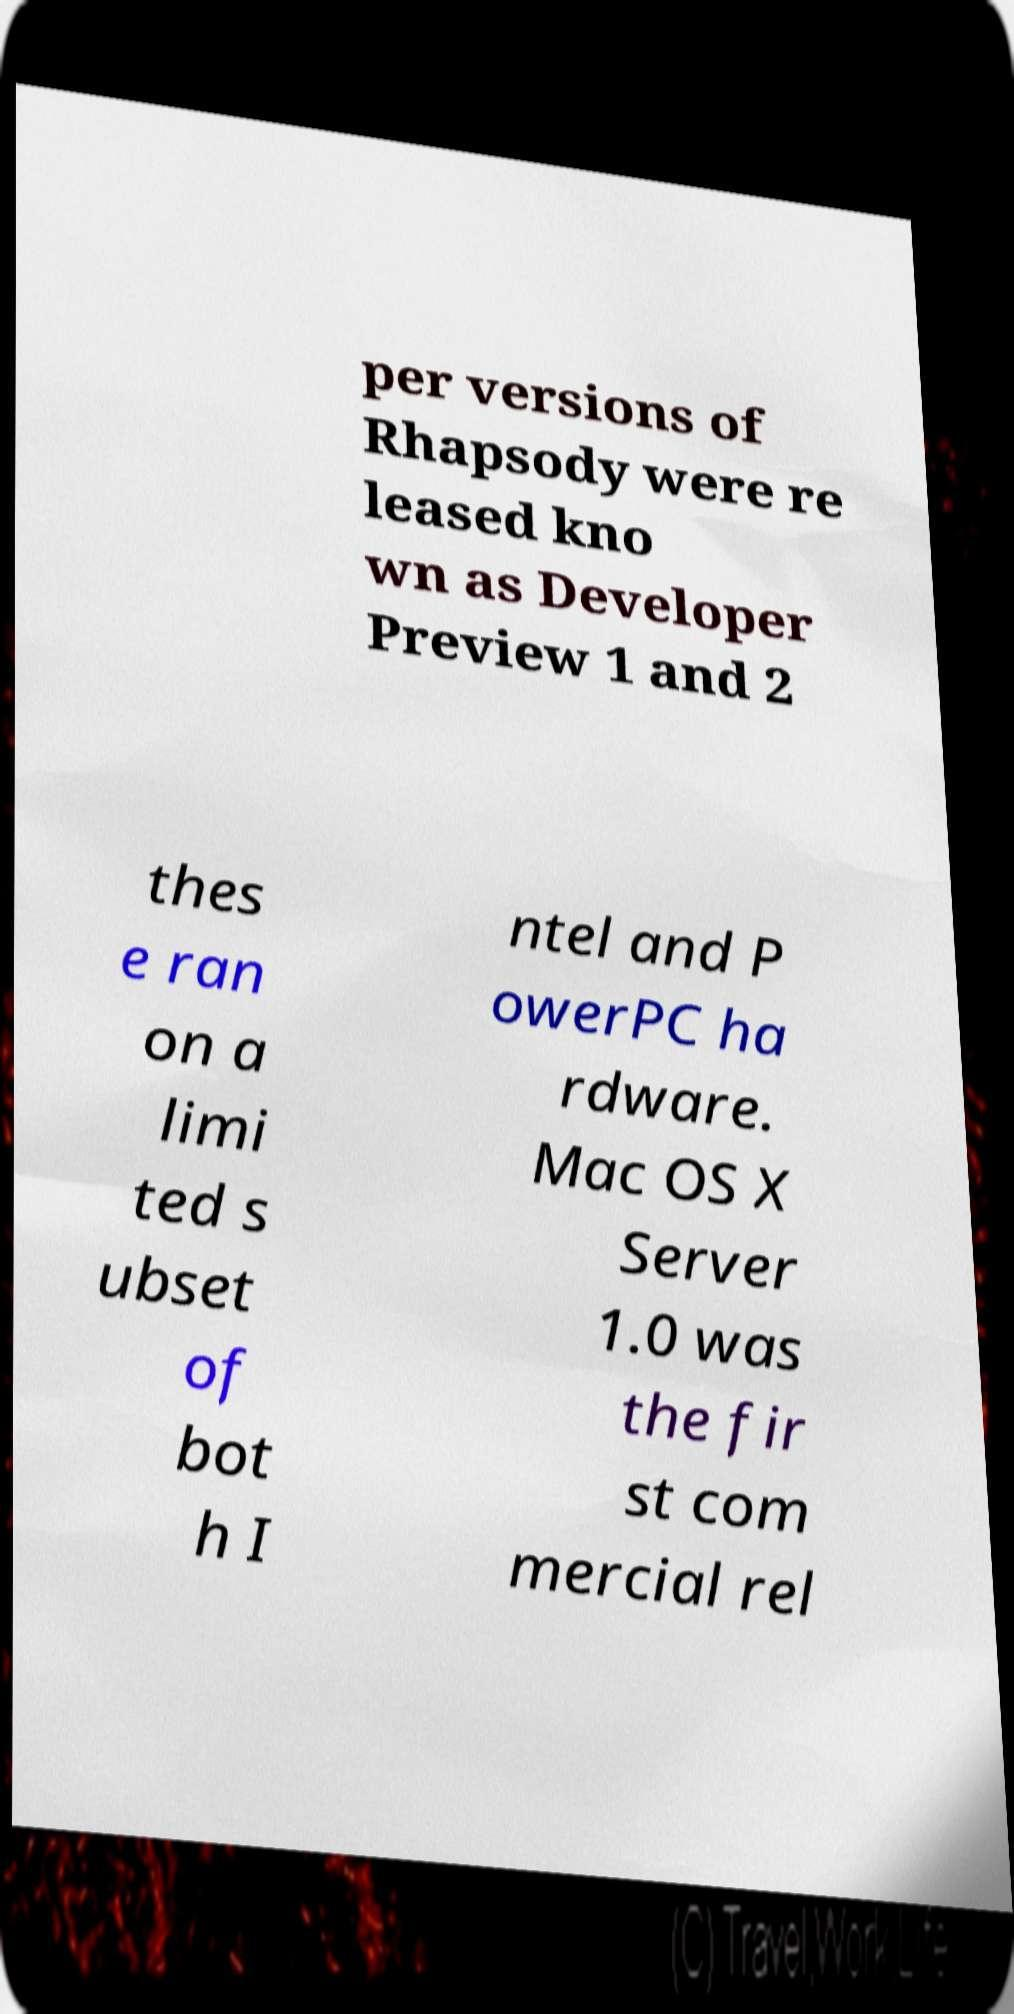Could you assist in decoding the text presented in this image and type it out clearly? per versions of Rhapsody were re leased kno wn as Developer Preview 1 and 2 thes e ran on a limi ted s ubset of bot h I ntel and P owerPC ha rdware. Mac OS X Server 1.0 was the fir st com mercial rel 